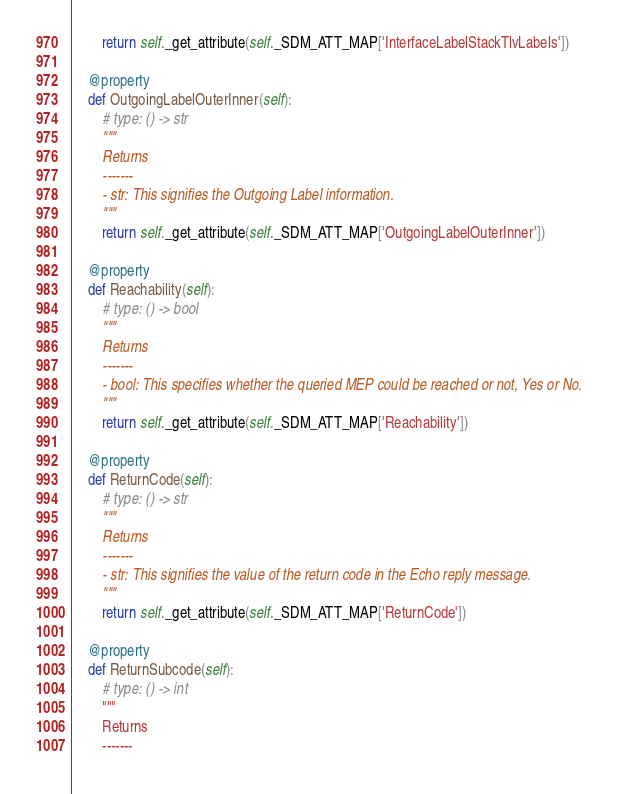Convert code to text. <code><loc_0><loc_0><loc_500><loc_500><_Python_>        return self._get_attribute(self._SDM_ATT_MAP['InterfaceLabelStackTlvLabels'])

    @property
    def OutgoingLabelOuterInner(self):
        # type: () -> str
        """
        Returns
        -------
        - str: This signifies the Outgoing Label information.
        """
        return self._get_attribute(self._SDM_ATT_MAP['OutgoingLabelOuterInner'])

    @property
    def Reachability(self):
        # type: () -> bool
        """
        Returns
        -------
        - bool: This specifies whether the queried MEP could be reached or not, Yes or No.
        """
        return self._get_attribute(self._SDM_ATT_MAP['Reachability'])

    @property
    def ReturnCode(self):
        # type: () -> str
        """
        Returns
        -------
        - str: This signifies the value of the return code in the Echo reply message.
        """
        return self._get_attribute(self._SDM_ATT_MAP['ReturnCode'])

    @property
    def ReturnSubcode(self):
        # type: () -> int
        """
        Returns
        -------</code> 